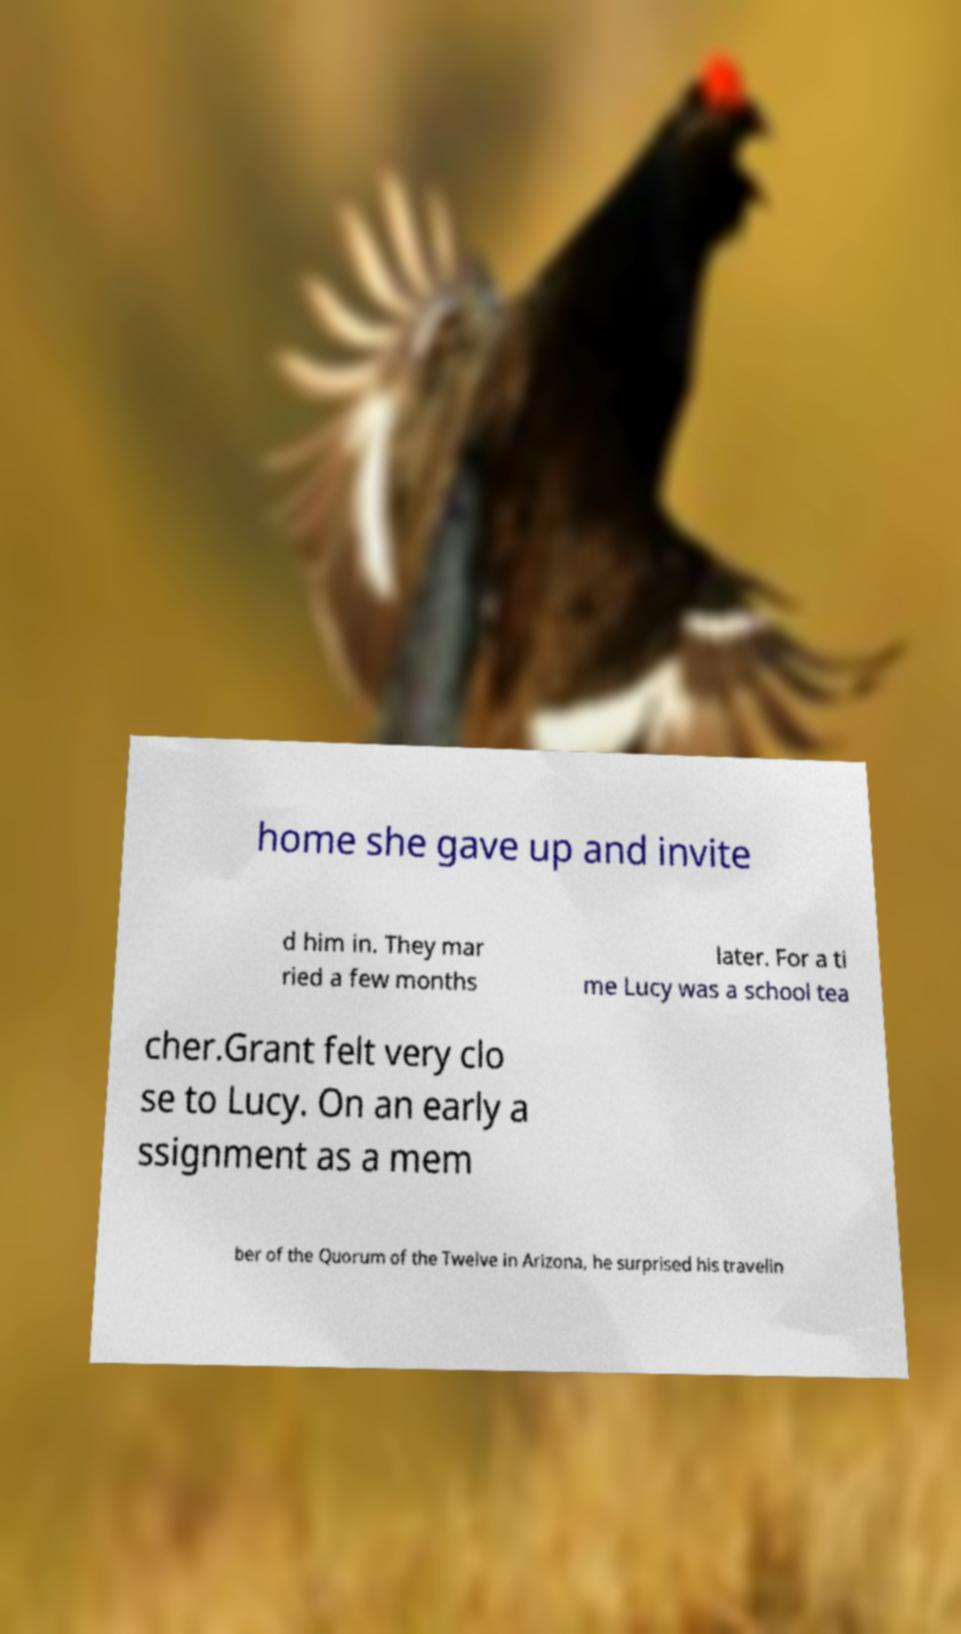Please read and relay the text visible in this image. What does it say? home she gave up and invite d him in. They mar ried a few months later. For a ti me Lucy was a school tea cher.Grant felt very clo se to Lucy. On an early a ssignment as a mem ber of the Quorum of the Twelve in Arizona, he surprised his travelin 